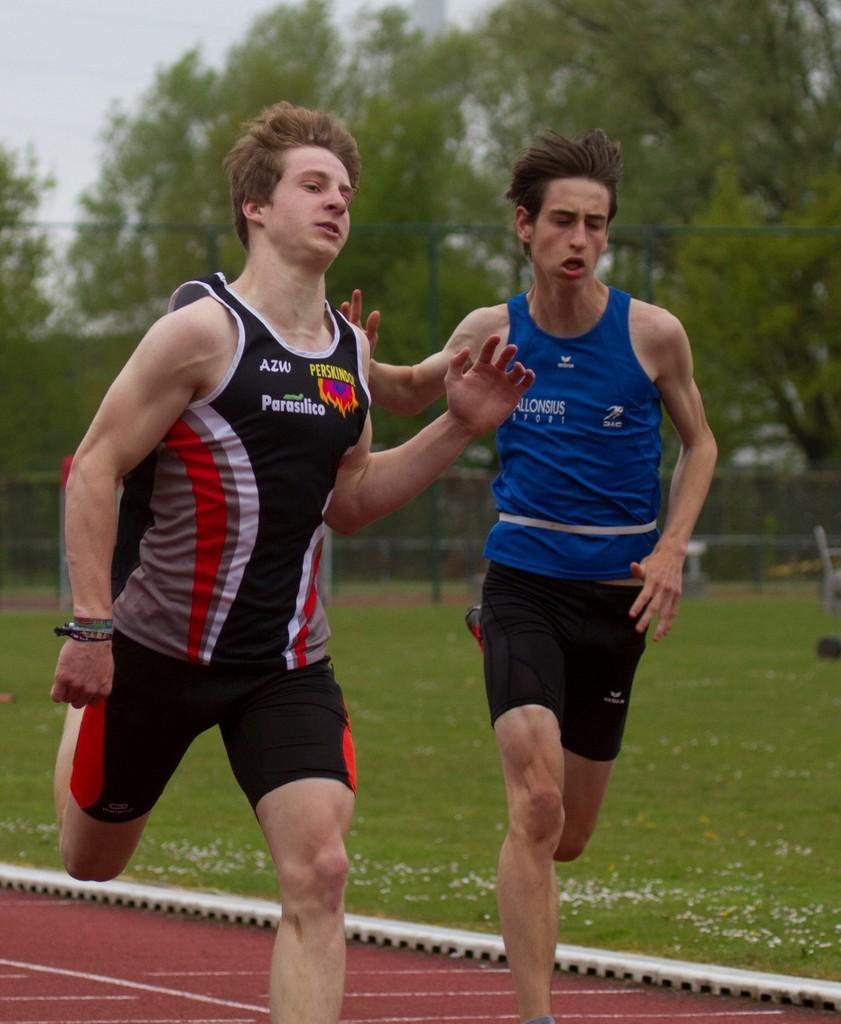Describe this image in one or two sentences. There are two men running. They wore T-shirts and shorts. Here is the grass. In the background, I can see the trees and the fence. 